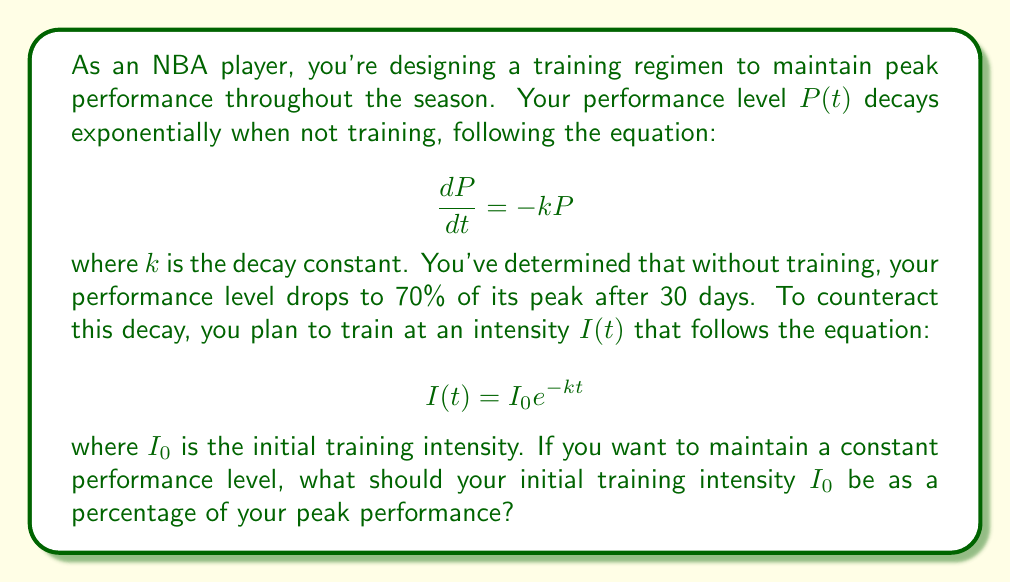What is the answer to this math problem? Let's approach this step-by-step:

1) First, we need to find the decay constant $k$. We know that after 30 days, the performance level is 70% of the peak. Let's call the peak performance $P_0$. Then:

   $$P(30) = 0.7P_0 = P_0e^{-k(30)}$$

2) Dividing both sides by $P_0$:

   $$0.7 = e^{-30k}$$

3) Taking the natural log of both sides:

   $$\ln(0.7) = -30k$$

4) Solving for $k$:

   $$k = -\frac{\ln(0.7)}{30} \approx 0.0119$$

5) Now, to maintain a constant performance level, the rate of training intensity must equal the rate of decay. In other words:

   $$\frac{dP}{dt} + I(t) = 0$$

6) Substituting our known equations:

   $$-kP + I_0e^{-kt} = 0$$

7) At $t=0$, $P = P_0$ (peak performance), so:

   $$-kP_0 + I_0 = 0$$

8) Solving for $I_0$:

   $$I_0 = kP_0$$

9) Substituting the value of $k$ we found earlier:

   $$I_0 = 0.0119P_0$$

10) To express this as a percentage of peak performance:

    $$\frac{I_0}{P_0} = 0.0119 = 1.19\%$$
Answer: The initial training intensity $I_0$ should be approximately 1.19% of your peak performance level. 